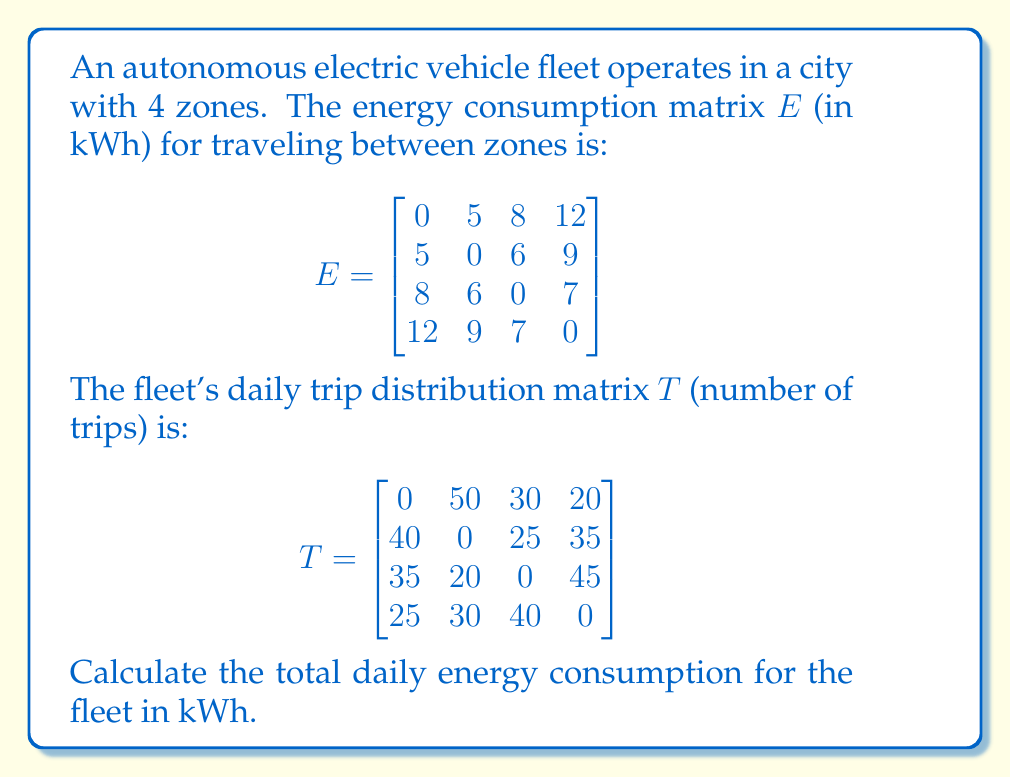Solve this math problem. To solve this problem, we need to follow these steps:

1) The energy consumption for each pair of zones is the product of the number of trips and the energy consumed per trip. This can be calculated by element-wise multiplication of matrices $E$ and $T$.

2) Let's call the resulting matrix $C$ (consumption matrix). To calculate $C$:

   $C_{ij} = E_{ij} \times T_{ij}$

3) Calculate each element of $C$:

   $$C = \begin{bmatrix}
   0 & 250 & 240 & 240 \\
   200 & 0 & 150 & 315 \\
   280 & 120 & 0 & 315 \\
   300 & 270 & 280 & 0
   \end{bmatrix}$$

4) The total energy consumption is the sum of all elements in matrix $C$.

5) Sum all elements:

   $0 + 250 + 240 + 240 + 200 + 0 + 150 + 315 + 280 + 120 + 0 + 315 + 300 + 270 + 280 + 0 = 2960$

Therefore, the total daily energy consumption for the fleet is 2960 kWh.
Answer: 2960 kWh 